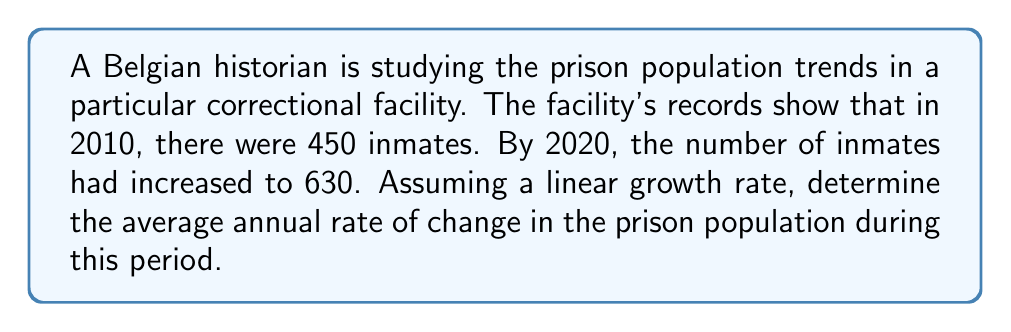What is the answer to this math problem? To solve this problem, we need to use the concept of rate of change. The rate of change is calculated by dividing the total change in a quantity by the time interval over which that change occurred.

Let's break it down step-by-step:

1. Identify the given information:
   * Initial population (2010): 450 inmates
   * Final population (2020): 630 inmates
   * Time interval: 10 years

2. Calculate the total change in population:
   $$\text{Change in population} = \text{Final population} - \text{Initial population}$$
   $$\text{Change in population} = 630 - 450 = 180 \text{ inmates}$$

3. Calculate the rate of change:
   $$\text{Rate of change} = \frac{\text{Change in population}}{\text{Time interval}}$$
   $$\text{Rate of change} = \frac{180 \text{ inmates}}{10 \text{ years}}$$
   $$\text{Rate of change} = 18 \text{ inmates per year}$$

This means that, on average, the prison population increased by 18 inmates each year between 2010 and 2020.
Answer: The average annual rate of change in the prison population is 18 inmates per year. 